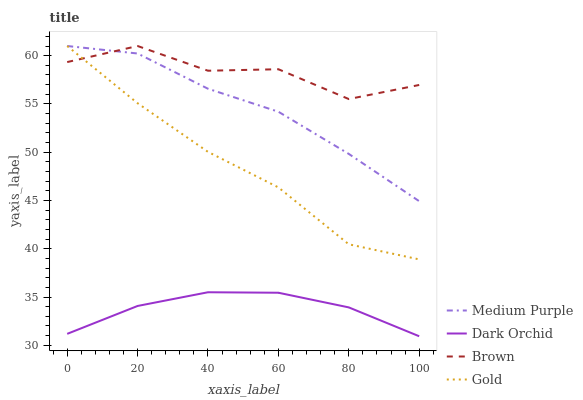Does Dark Orchid have the minimum area under the curve?
Answer yes or no. Yes. Does Brown have the maximum area under the curve?
Answer yes or no. Yes. Does Gold have the minimum area under the curve?
Answer yes or no. No. Does Gold have the maximum area under the curve?
Answer yes or no. No. Is Dark Orchid the smoothest?
Answer yes or no. Yes. Is Brown the roughest?
Answer yes or no. Yes. Is Gold the smoothest?
Answer yes or no. No. Is Gold the roughest?
Answer yes or no. No. Does Gold have the lowest value?
Answer yes or no. No. Does Gold have the highest value?
Answer yes or no. Yes. Does Dark Orchid have the highest value?
Answer yes or no. No. Is Dark Orchid less than Medium Purple?
Answer yes or no. Yes. Is Gold greater than Dark Orchid?
Answer yes or no. Yes. Does Brown intersect Medium Purple?
Answer yes or no. Yes. Is Brown less than Medium Purple?
Answer yes or no. No. Is Brown greater than Medium Purple?
Answer yes or no. No. Does Dark Orchid intersect Medium Purple?
Answer yes or no. No. 